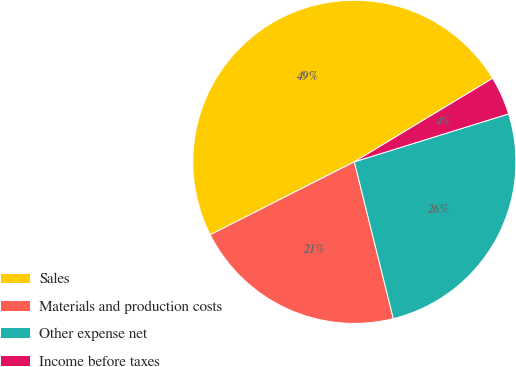Convert chart to OTSL. <chart><loc_0><loc_0><loc_500><loc_500><pie_chart><fcel>Sales<fcel>Materials and production costs<fcel>Other expense net<fcel>Income before taxes<nl><fcel>48.82%<fcel>21.42%<fcel>25.92%<fcel>3.85%<nl></chart> 